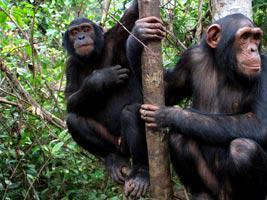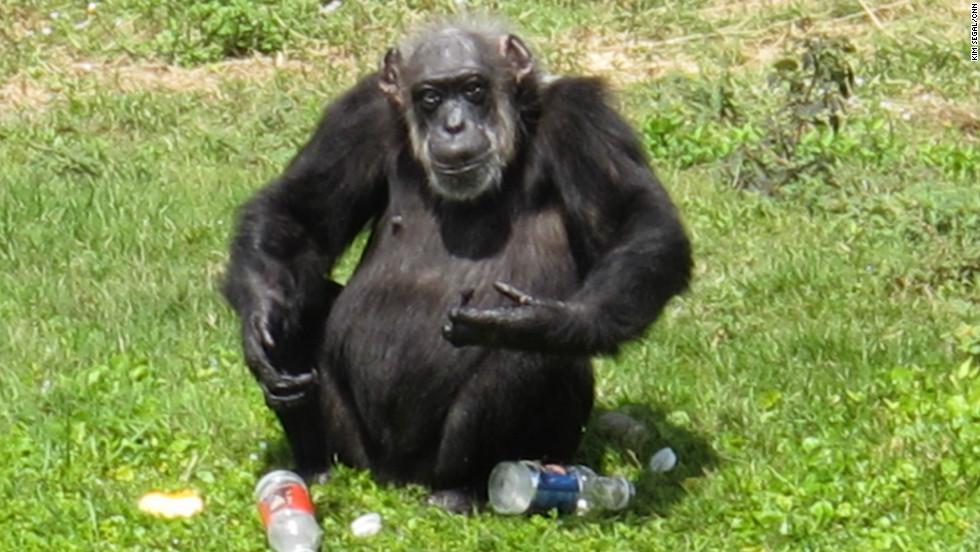The first image is the image on the left, the second image is the image on the right. Given the left and right images, does the statement "At least one of the images contains exactly three monkeys." hold true? Answer yes or no. No. 